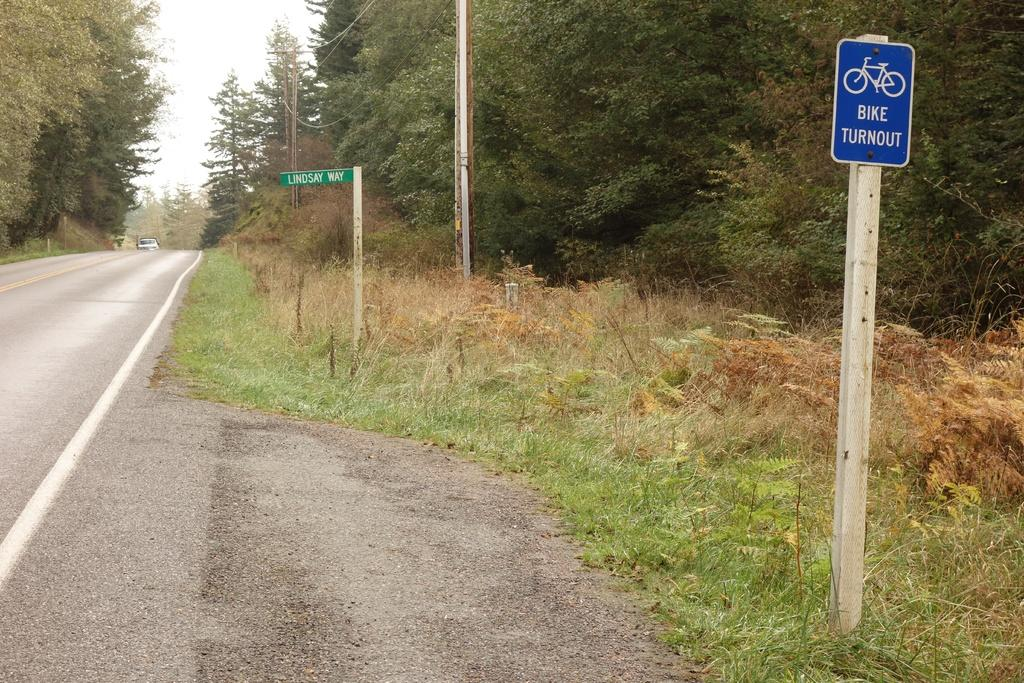<image>
Write a terse but informative summary of the picture. a sign that says bike turnout that is blue 